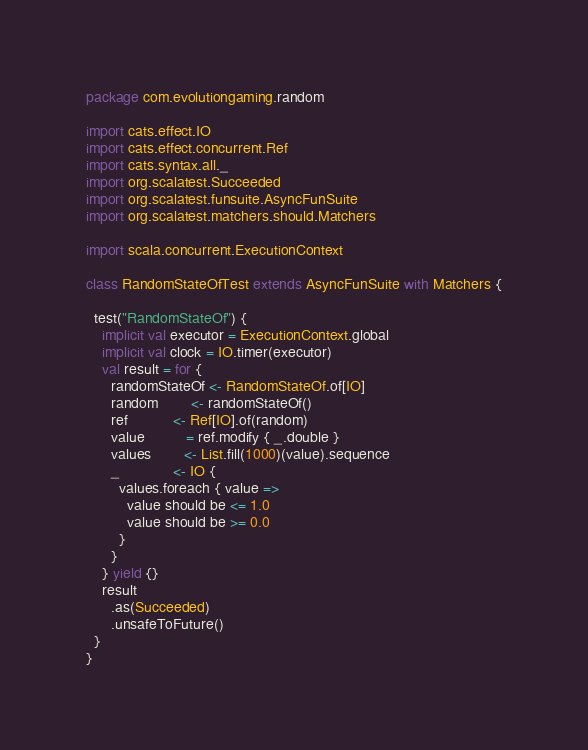Convert code to text. <code><loc_0><loc_0><loc_500><loc_500><_Scala_>package com.evolutiongaming.random

import cats.effect.IO
import cats.effect.concurrent.Ref
import cats.syntax.all._
import org.scalatest.Succeeded
import org.scalatest.funsuite.AsyncFunSuite
import org.scalatest.matchers.should.Matchers

import scala.concurrent.ExecutionContext

class RandomStateOfTest extends AsyncFunSuite with Matchers {

  test("RandomStateOf") {
    implicit val executor = ExecutionContext.global
    implicit val clock = IO.timer(executor)
    val result = for {
      randomStateOf <- RandomStateOf.of[IO]
      random        <- randomStateOf()
      ref           <- Ref[IO].of(random)
      value          = ref.modify { _.double }
      values        <- List.fill(1000)(value).sequence
      _             <- IO {
        values.foreach { value =>
          value should be <= 1.0
          value should be >= 0.0
        }
      }
    } yield {}
    result
      .as(Succeeded)
      .unsafeToFuture()
  }
}
</code> 